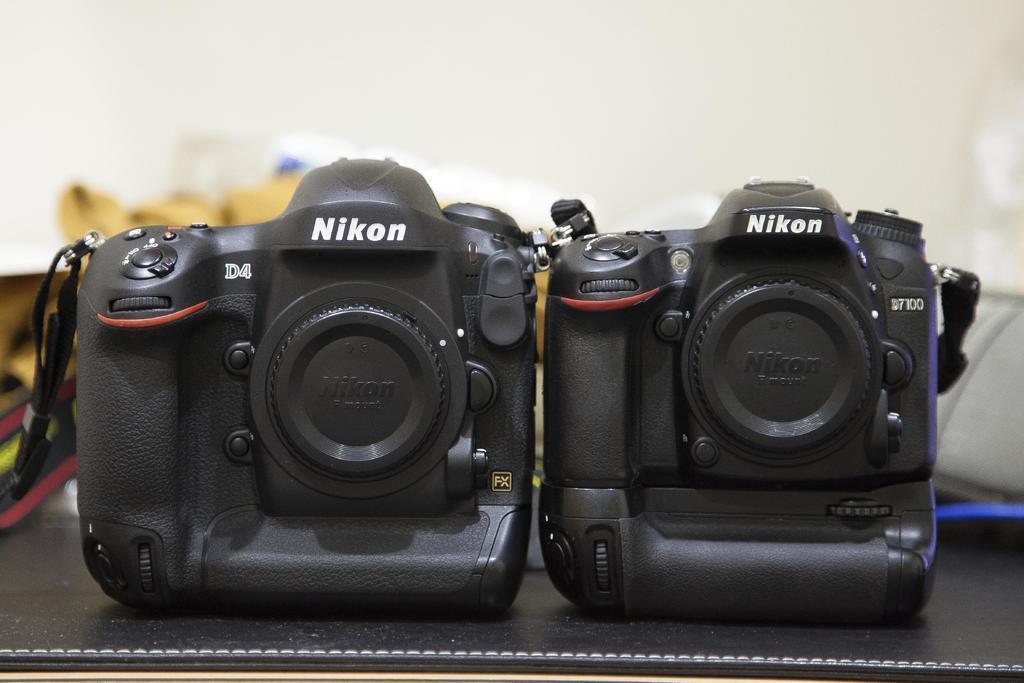Please provide a concise description of this image. In this image, there are cameras on blur background. 